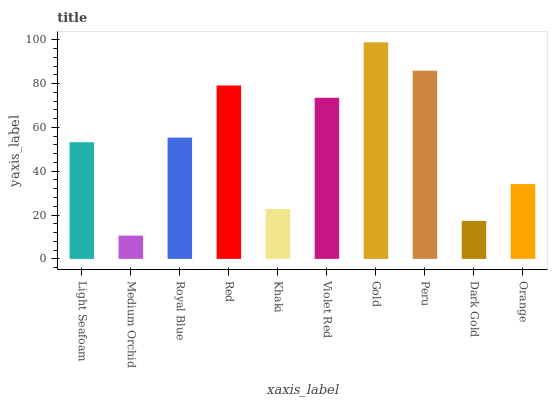Is Medium Orchid the minimum?
Answer yes or no. Yes. Is Gold the maximum?
Answer yes or no. Yes. Is Royal Blue the minimum?
Answer yes or no. No. Is Royal Blue the maximum?
Answer yes or no. No. Is Royal Blue greater than Medium Orchid?
Answer yes or no. Yes. Is Medium Orchid less than Royal Blue?
Answer yes or no. Yes. Is Medium Orchid greater than Royal Blue?
Answer yes or no. No. Is Royal Blue less than Medium Orchid?
Answer yes or no. No. Is Royal Blue the high median?
Answer yes or no. Yes. Is Light Seafoam the low median?
Answer yes or no. Yes. Is Medium Orchid the high median?
Answer yes or no. No. Is Orange the low median?
Answer yes or no. No. 